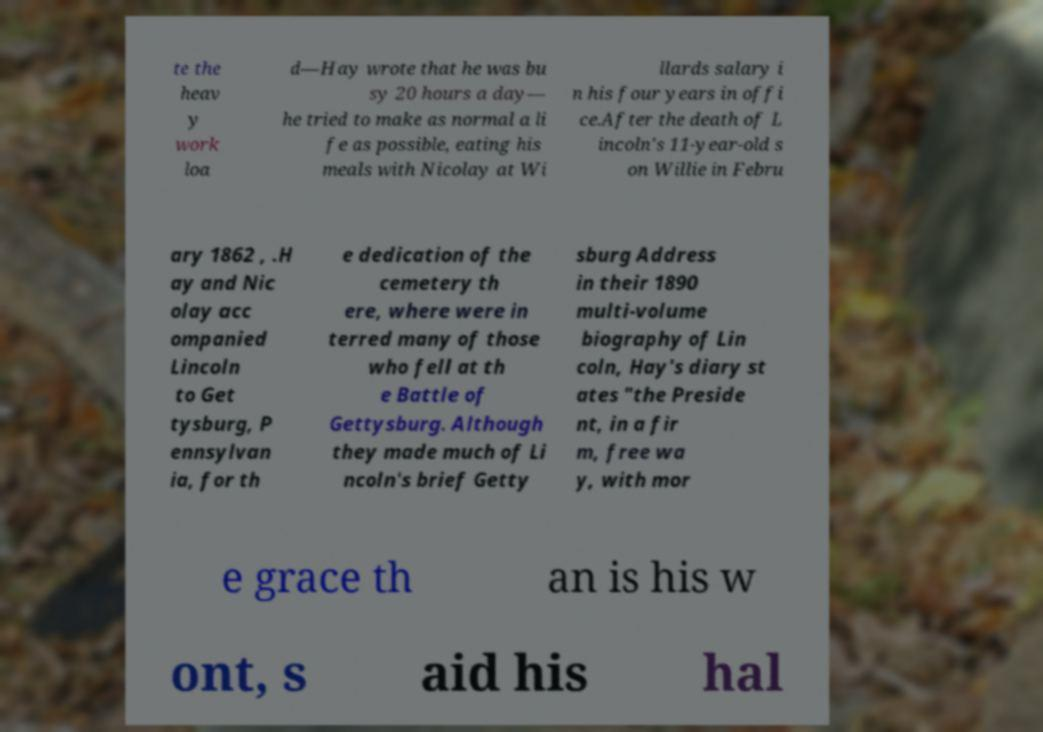Please read and relay the text visible in this image. What does it say? te the heav y work loa d—Hay wrote that he was bu sy 20 hours a day— he tried to make as normal a li fe as possible, eating his meals with Nicolay at Wi llards salary i n his four years in offi ce.After the death of L incoln's 11-year-old s on Willie in Febru ary 1862 , .H ay and Nic olay acc ompanied Lincoln to Get tysburg, P ennsylvan ia, for th e dedication of the cemetery th ere, where were in terred many of those who fell at th e Battle of Gettysburg. Although they made much of Li ncoln's brief Getty sburg Address in their 1890 multi-volume biography of Lin coln, Hay's diary st ates "the Preside nt, in a fir m, free wa y, with mor e grace th an is his w ont, s aid his hal 